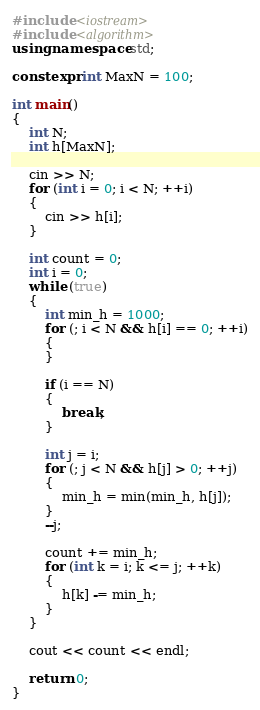Convert code to text. <code><loc_0><loc_0><loc_500><loc_500><_C++_>#include <iostream>
#include <algorithm>
using namespace std;

constexpr int MaxN = 100;

int main()
{
	int N;
	int h[MaxN];

	cin >> N;
	for (int i = 0; i < N; ++i)
	{
		cin >> h[i];
	}

	int count = 0;
	int i = 0;
	while (true)
	{
		int min_h = 1000;
		for (; i < N && h[i] == 0; ++i)
		{
		}

		if (i == N)
		{
			break;
		}

		int j = i;
		for (; j < N && h[j] > 0; ++j)
		{
			min_h = min(min_h, h[j]);
		}
		--j;

		count += min_h;
		for (int k = i; k <= j; ++k)
		{
			h[k] -= min_h;
		}
	}

	cout << count << endl;

	return 0;
}</code> 